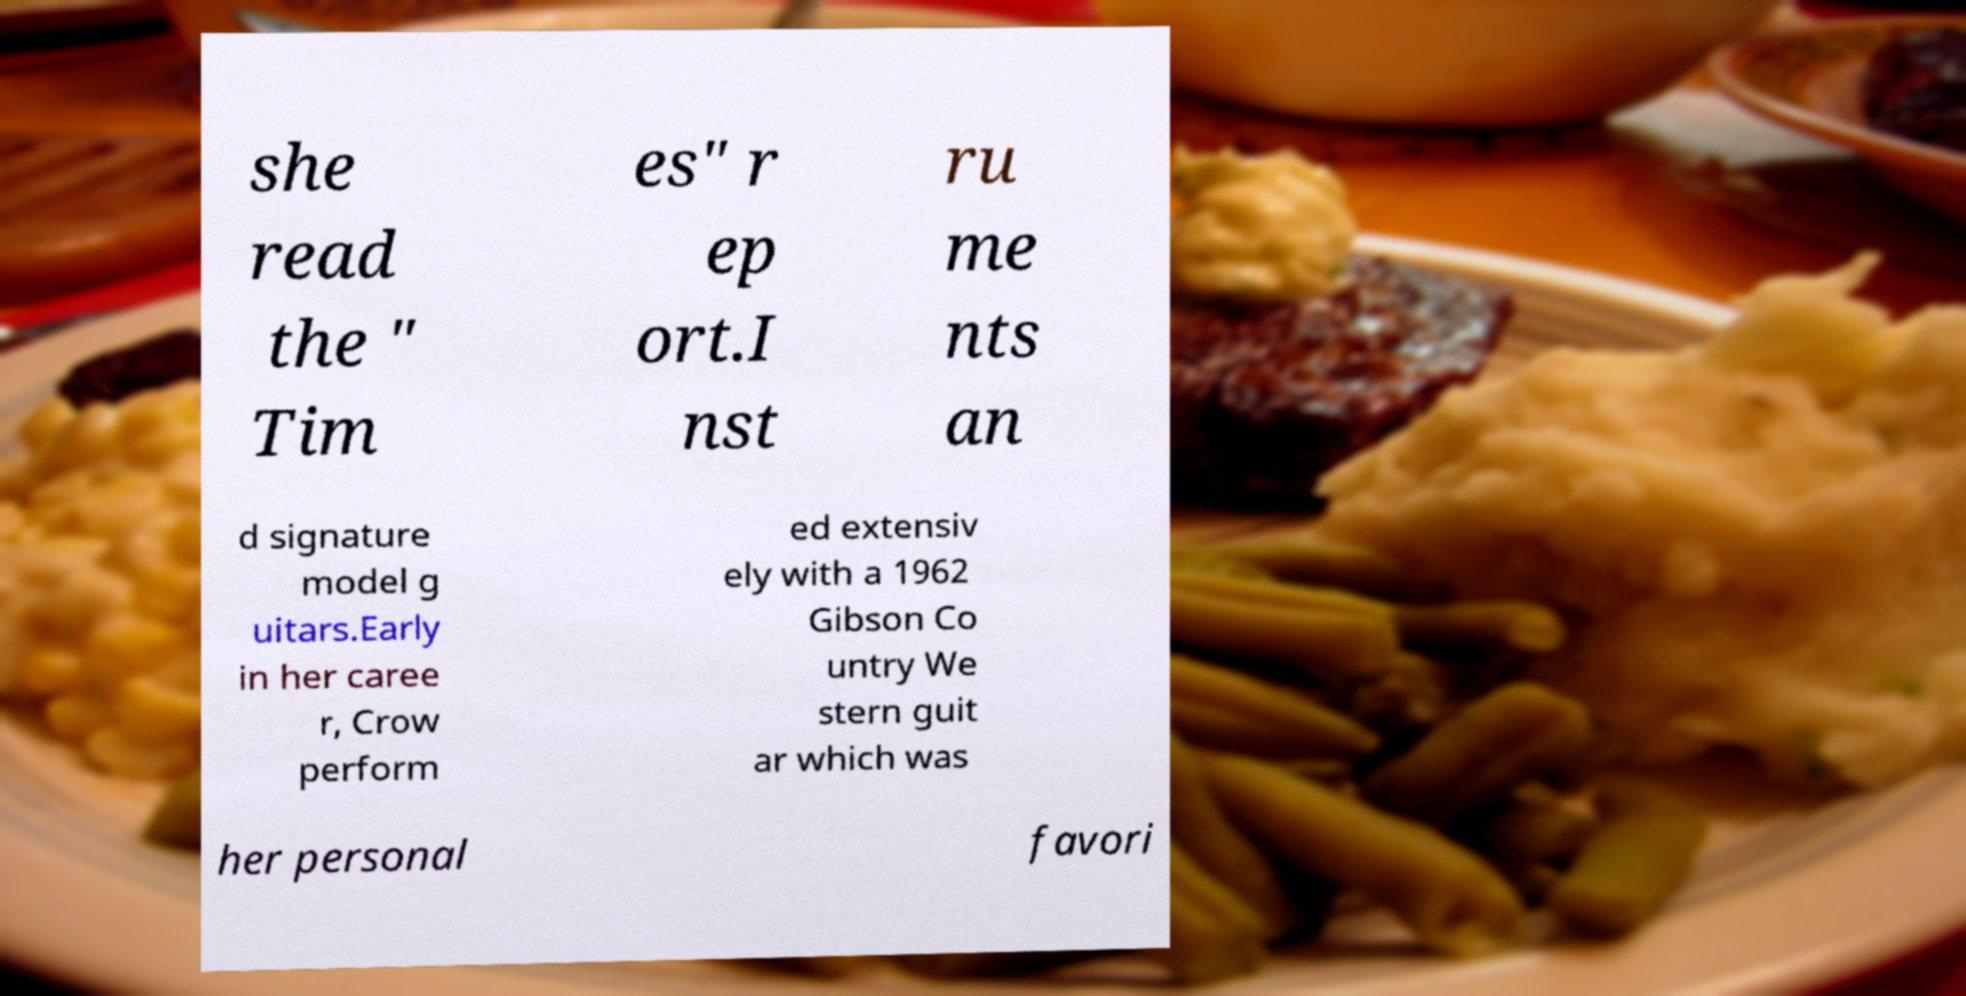Could you assist in decoding the text presented in this image and type it out clearly? she read the " Tim es" r ep ort.I nst ru me nts an d signature model g uitars.Early in her caree r, Crow perform ed extensiv ely with a 1962 Gibson Co untry We stern guit ar which was her personal favori 